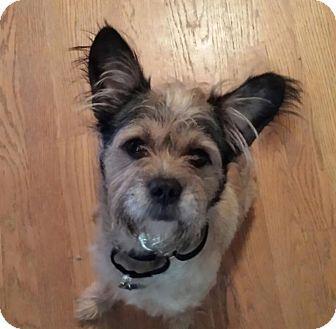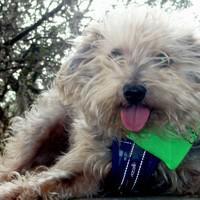The first image is the image on the left, the second image is the image on the right. Analyze the images presented: Is the assertion "None of the dogs' tongues are visible." valid? Answer yes or no. No. The first image is the image on the left, the second image is the image on the right. For the images shown, is this caption "the right side image has a dog that has their tongue out" true? Answer yes or no. Yes. 